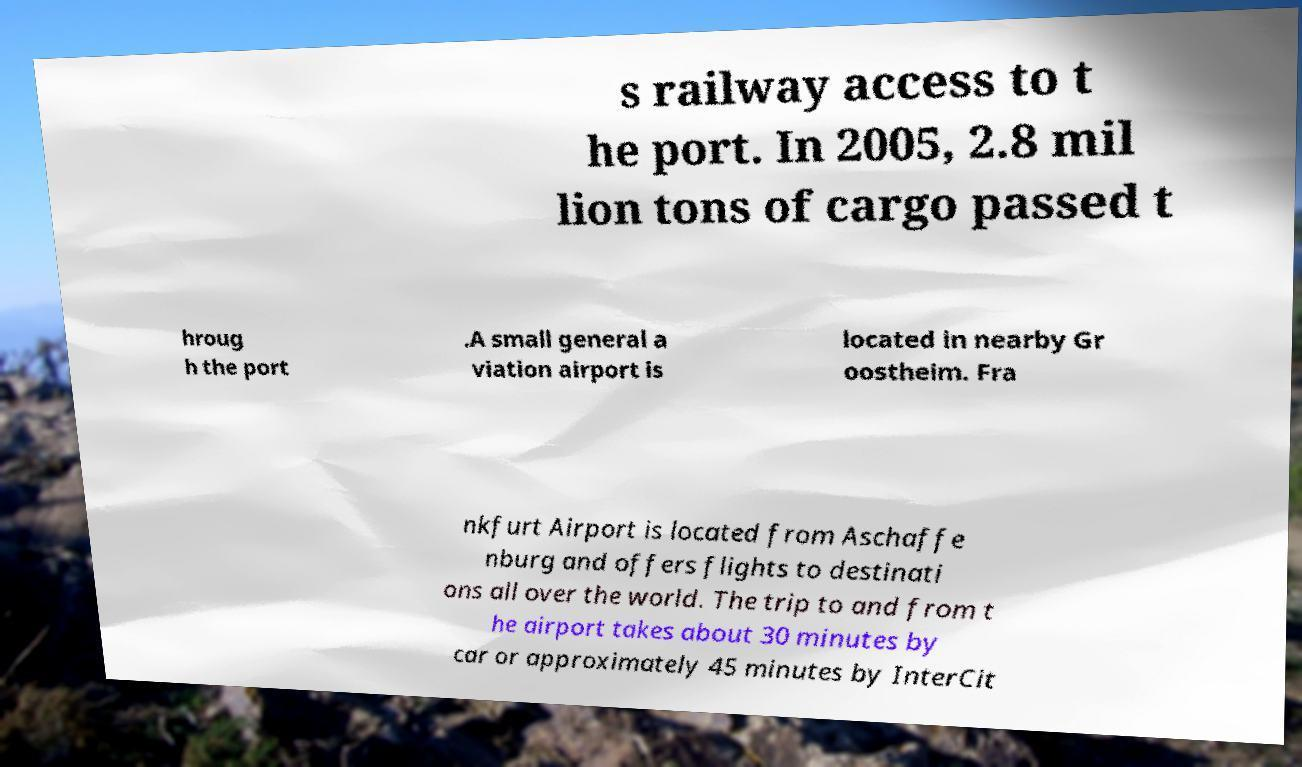Please read and relay the text visible in this image. What does it say? s railway access to t he port. In 2005, 2.8 mil lion tons of cargo passed t hroug h the port .A small general a viation airport is located in nearby Gr oostheim. Fra nkfurt Airport is located from Aschaffe nburg and offers flights to destinati ons all over the world. The trip to and from t he airport takes about 30 minutes by car or approximately 45 minutes by InterCit 